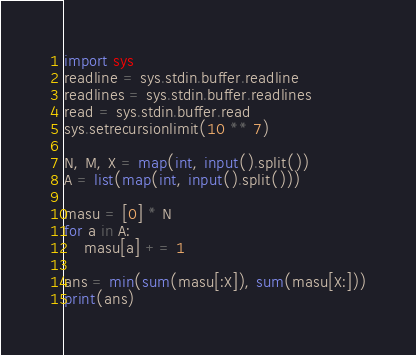<code> <loc_0><loc_0><loc_500><loc_500><_Python_>import sys
readline = sys.stdin.buffer.readline
readlines = sys.stdin.buffer.readlines
read = sys.stdin.buffer.read
sys.setrecursionlimit(10 ** 7)

N, M, X = map(int, input().split())
A = list(map(int, input().split()))

masu = [0] * N
for a in A:
    masu[a] += 1

ans = min(sum(masu[:X]), sum(masu[X:]))
print(ans)</code> 